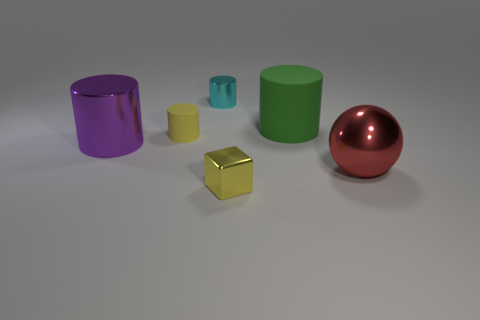How many other yellow matte things have the same shape as the tiny yellow rubber thing?
Offer a terse response. 0. What is the shape of the small yellow matte object?
Your answer should be compact. Cylinder. Are there fewer small purple things than big metallic spheres?
Ensure brevity in your answer.  Yes. Is there any other thing that has the same size as the purple metal thing?
Give a very brief answer. Yes. What is the material of the cyan object that is the same shape as the purple object?
Make the answer very short. Metal. Is the number of tiny yellow metallic objects greater than the number of small yellow objects?
Offer a very short reply. No. How many other things are the same color as the big rubber cylinder?
Your answer should be compact. 0. Is the material of the yellow block the same as the small cylinder on the left side of the tiny cyan object?
Provide a succinct answer. No. There is a large shiny thing to the right of the small yellow thing that is in front of the red ball; how many big purple cylinders are left of it?
Provide a succinct answer. 1. Is the number of big red things that are in front of the big green matte thing less than the number of yellow metal blocks that are to the right of the large purple thing?
Offer a terse response. No. 